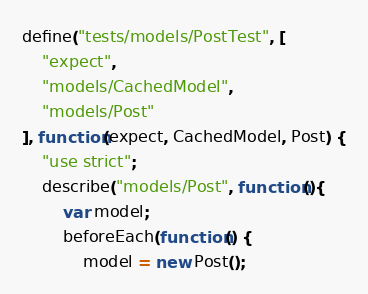<code> <loc_0><loc_0><loc_500><loc_500><_JavaScript_>define("tests/models/PostTest", [
    "expect",
    "models/CachedModel",
    "models/Post"
], function(expect, CachedModel, Post) {
    "use strict";
    describe("models/Post", function(){
        var model;
        beforeEach(function() {
			model = new Post();</code> 